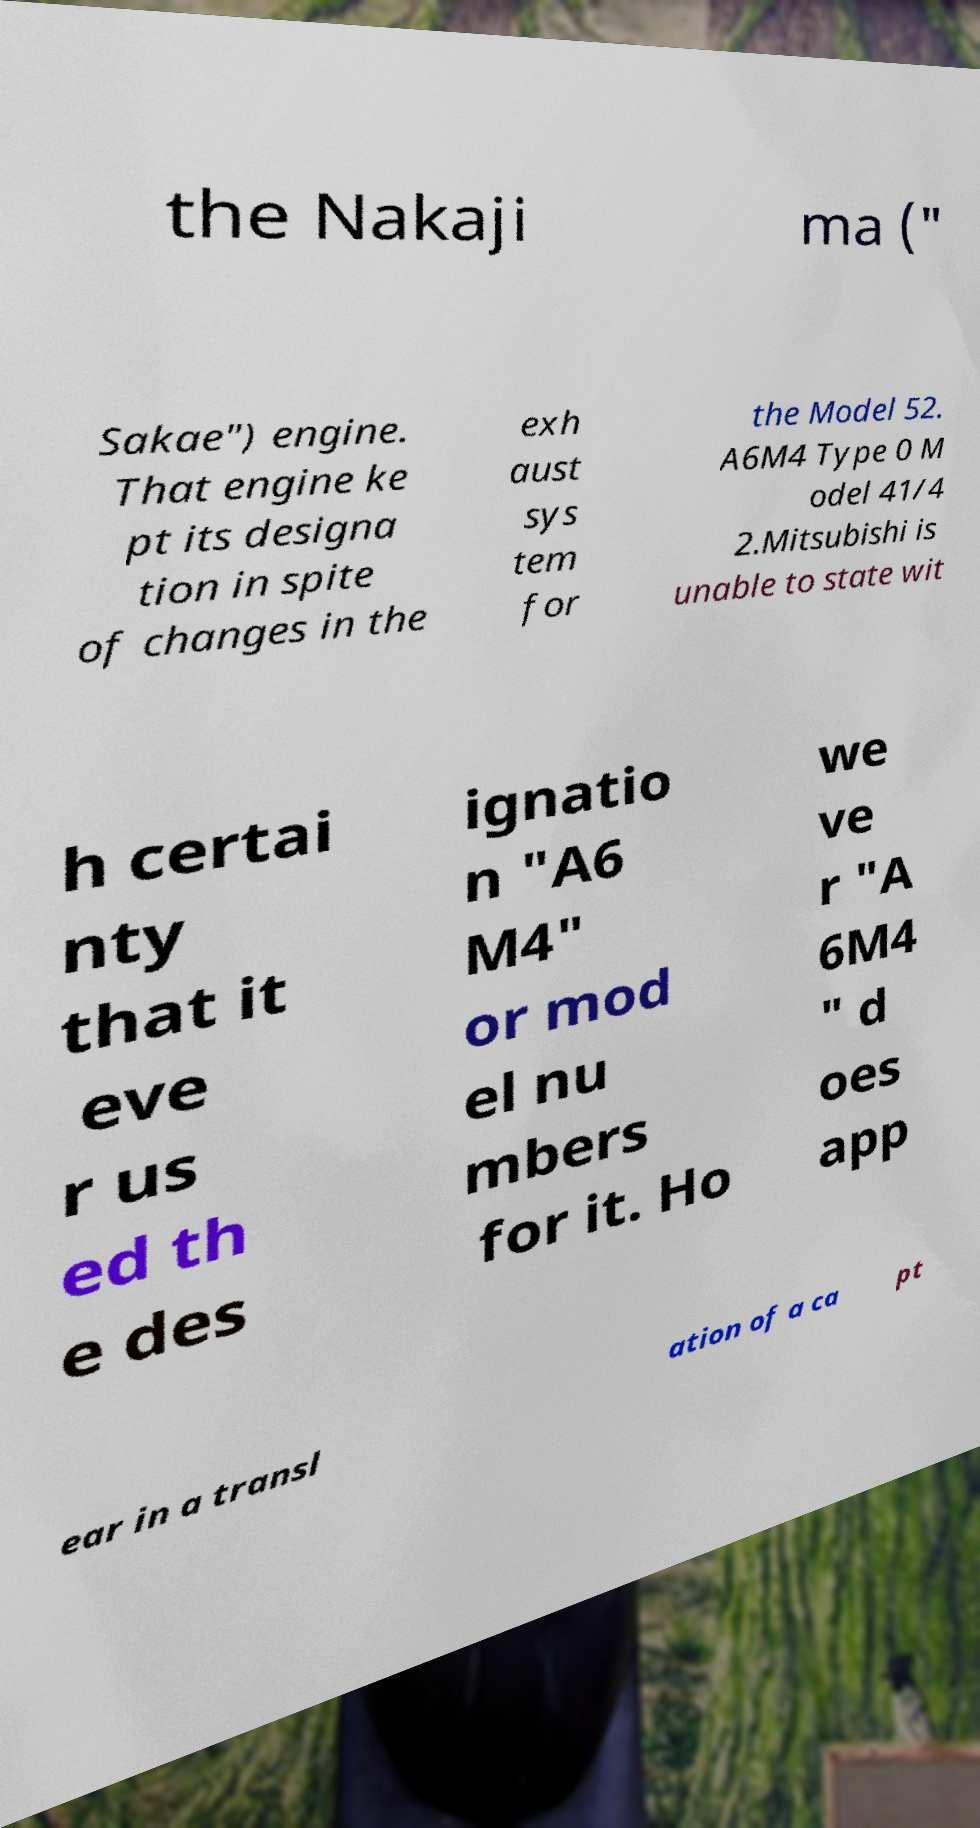Could you assist in decoding the text presented in this image and type it out clearly? the Nakaji ma (" Sakae") engine. That engine ke pt its designa tion in spite of changes in the exh aust sys tem for the Model 52. A6M4 Type 0 M odel 41/4 2.Mitsubishi is unable to state wit h certai nty that it eve r us ed th e des ignatio n "A6 M4" or mod el nu mbers for it. Ho we ve r "A 6M4 " d oes app ear in a transl ation of a ca pt 